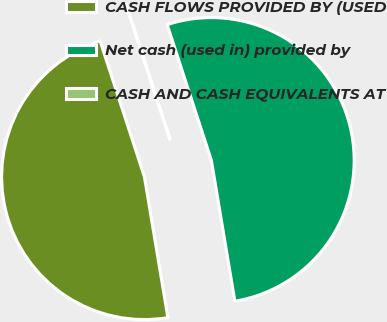Convert chart to OTSL. <chart><loc_0><loc_0><loc_500><loc_500><pie_chart><fcel>CASH FLOWS PROVIDED BY (USED<fcel>Net cash (used in) provided by<fcel>CASH AND CASH EQUIVALENTS AT<nl><fcel>47.61%<fcel>52.38%<fcel>0.01%<nl></chart> 